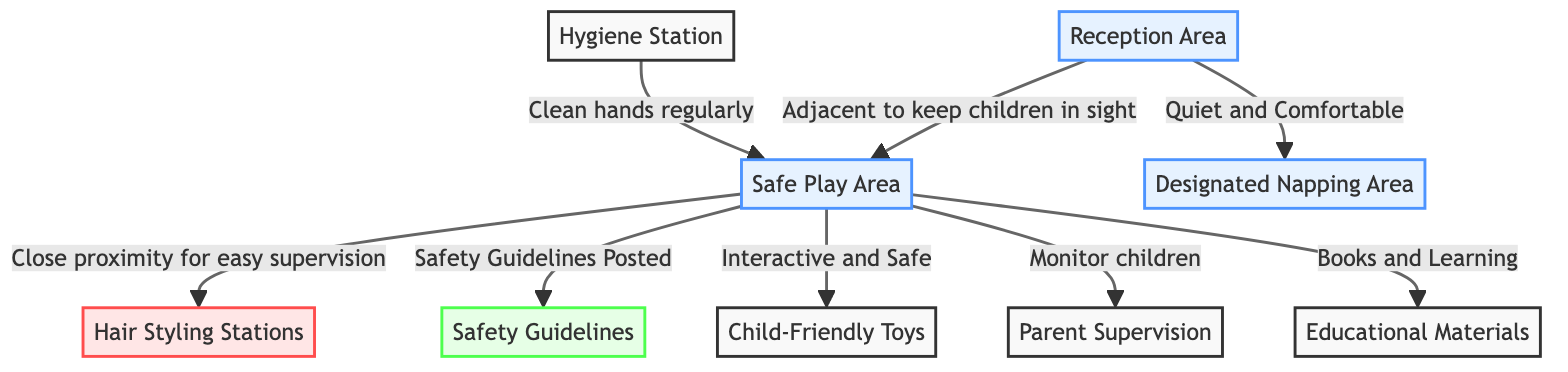What is next to the reception area? The diagram indicates that the play area is adjacent to the reception area, so the child play area is positioned right next to it.
Answer: Play Area What connects the play area to the hair styling stations? The diagram shows that the play area is in close proximity to the hair styling stations, which facilitates easy supervision of children playing while parents get their hair styled.
Answer: Close proximity What safety aspect is specifically mentioned in the play area? The diagram highlights that safety guidelines are posted within the play area, indicating that there are established rules for ensuring children's safety while playing.
Answer: Safety Guidelines Posted How many areas are designated for child care in the salon? The diagram shows two specified areas for child care: the designated napping area and the safe play area.
Answer: Two What is indicated next to the hygiene station? According to the diagram, the hygiene station is linked to the play area with the purpose of maintaining cleanliness by ensuring clean hands regularly.
Answer: Clean hands regularly Which element is directly related to supervision in the play area? The diagram connects parent supervision as a key element within the play area, ensuring parents can monitor their children as they're engaged in play.
Answer: Parent Supervision What type of materials are specified for educational purposes in the play area? The diagram outlines that educational materials are available in the play area, indicating that books and other learning resources are provided for children.
Answer: Educational Materials Which area is described as quiet and comfortable? The designated napping area is specifically characterized as quiet and comfortable in the diagram, meant for children who need to rest.
Answer: Designated Napping Area What type of toys are mentioned in relation to safety in the play area? Child-friendly toys are pointed out as being interactive and safe for children to use while playing in the play area.
Answer: Child-Friendly Toys 